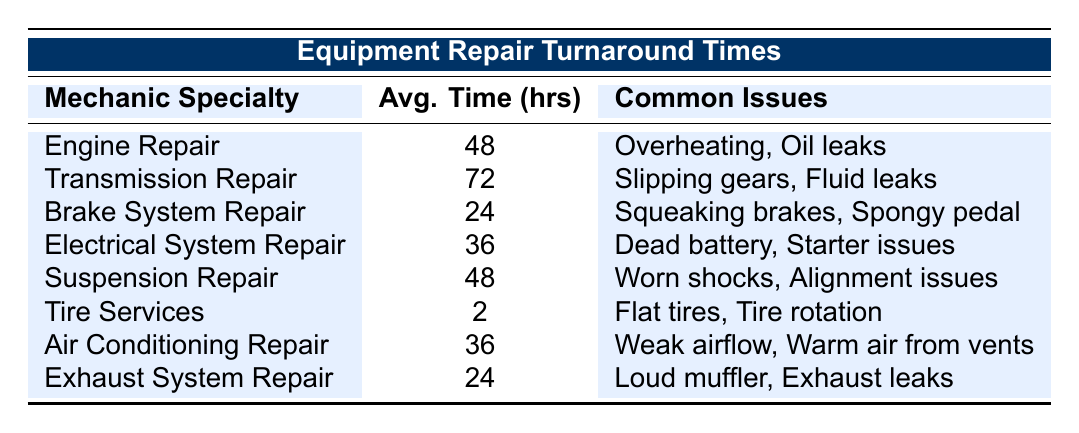What is the average turnaround time for Brake System Repair? Looking at the table, the average turnaround time for Brake System Repair is listed under the Avg. Time column. It shows 24 hours.
Answer: 24 hours Which mechanic specialty has the longest average turnaround time? By reviewing the Avg. Time column, Transmission Repair shows the highest value at 72 hours, making it the longest average turnaround time among the specialties.
Answer: Transmission Repair True or False: Air Conditioning Repair takes less time than Suspension Repair. Checking the average turnaround times, Air Conditioning Repair is listed as 36 hours while Suspension Repair is 48 hours. Therefore, the statement is true: Air Conditioning Repair takes less time.
Answer: True What is the difference in average turnaround time between Electrical System Repair and Brake System Repair? From the table, Electrical System Repair has an average time of 36 hours, and Brake System Repair has 24 hours. The difference is calculated as 36 - 24 = 12 hours.
Answer: 12 hours If a vehicle requires Tire Services and Exhaust System Repair, what is the total average turnaround time? Tire Services has an average of 2 hours, and Exhaust System Repair has 24 hours. Adding these together gives 2 + 24 = 26 hours as the total average turnaround time.
Answer: 26 hours Which mechanic specialties have an average turnaround time of 36 hours? The table indicates that both Electrical System Repair and Air Conditioning Repair have an average turnaround time of 36 hours. Therefore, both specialties meet the criteria.
Answer: Electrical System Repair and Air Conditioning Repair What is the average turnaround time for all specialties combined? To find the average, sum the average times of all specialties: 48 + 72 + 24 + 36 + 48 + 2 + 36 + 24 = 290 hours. Since there are 8 specialties, the average is 290/8 = 36.25 hours.
Answer: 36.25 hours Which common issues are associated with Transmission Repair? The table lists common issues for each mechanic specialty. For Transmission Repair, the common issues are Slipping gears, Fluid leaks, and Torque converter failure, directly read from the table.
Answer: Slipping gears, Fluid leaks, Torque converter failure How many specialties have an average turnaround time of 48 hours? The table lists two specialties with 48 hours: Engine Repair and Suspension Repair. Therefore, there are two specialties in this category.
Answer: 2 specialties What are the sample brands associated with Brake System Repair? By looking at the table, under Brake System Repair, the sample brands listed are Subaru, Hyundai, and Kia. This can be directly referenced from the data provided in the table.
Answer: Subaru, Hyundai, Kia 